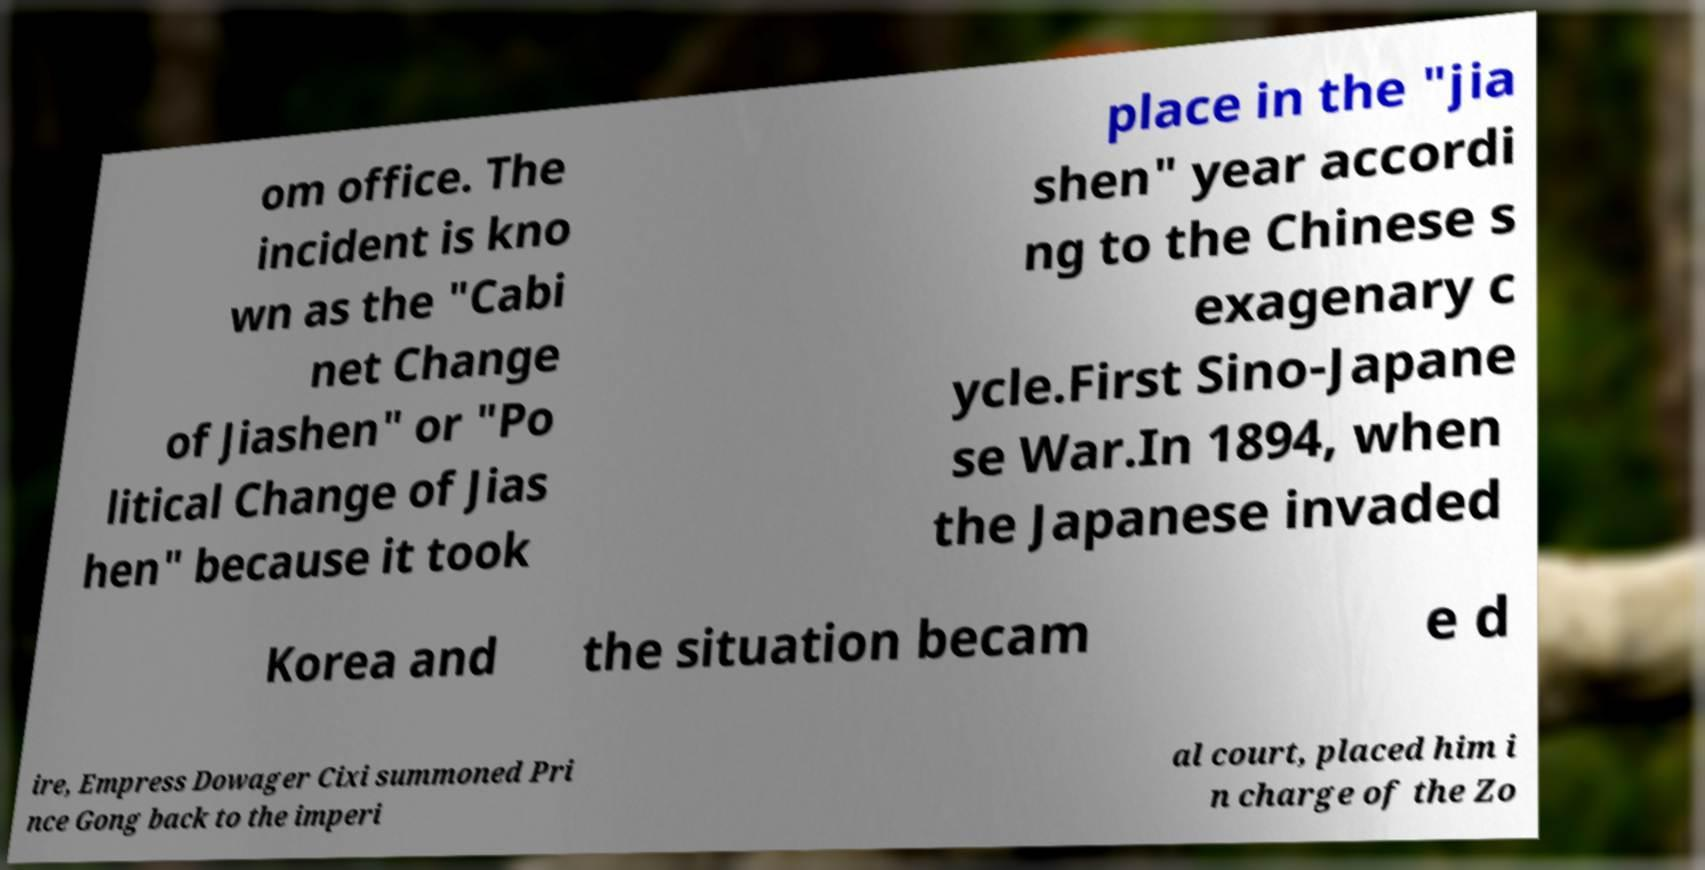There's text embedded in this image that I need extracted. Can you transcribe it verbatim? om office. The incident is kno wn as the "Cabi net Change of Jiashen" or "Po litical Change of Jias hen" because it took place in the "jia shen" year accordi ng to the Chinese s exagenary c ycle.First Sino-Japane se War.In 1894, when the Japanese invaded Korea and the situation becam e d ire, Empress Dowager Cixi summoned Pri nce Gong back to the imperi al court, placed him i n charge of the Zo 